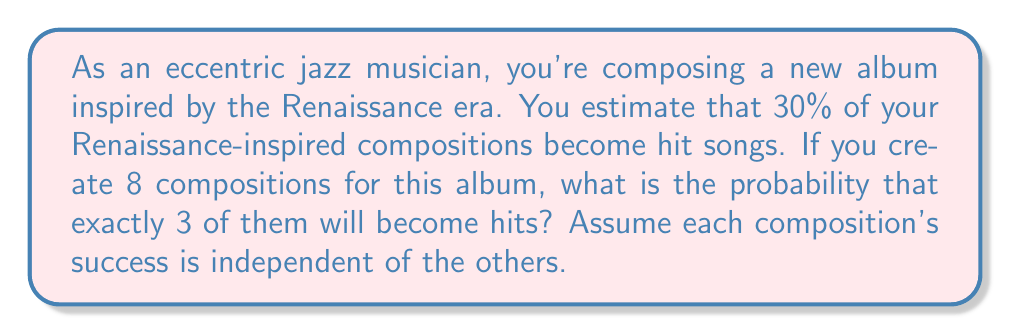Teach me how to tackle this problem. To solve this problem, we can use the Binomial probability distribution, as we have a fixed number of independent trials (compositions) with two possible outcomes (hit or not hit) and a constant probability of success.

Let's break it down step-by-step:

1) Define the variables:
   $n = 8$ (number of compositions)
   $k = 3$ (number of desired hits)
   $p = 0.30$ (probability of a composition being a hit)

2) The Binomial probability formula is:

   $$P(X = k) = \binom{n}{k} p^k (1-p)^{n-k}$$

3) Calculate the binomial coefficient:

   $$\binom{8}{3} = \frac{8!}{3!(8-3)!} = \frac{8!}{3!5!} = 56$$

4) Substitute the values into the formula:

   $$P(X = 3) = 56 \cdot (0.30)^3 \cdot (1-0.30)^{8-3}$$

5) Simplify:

   $$P(X = 3) = 56 \cdot (0.30)^3 \cdot (0.70)^5$$

6) Calculate:

   $$P(X = 3) = 56 \cdot 0.027 \cdot 0.16807 \approx 0.2541$$

Therefore, the probability of exactly 3 out of 8 Renaissance-inspired compositions becoming hits is approximately 0.2541 or 25.41%.
Answer: 0.2541 